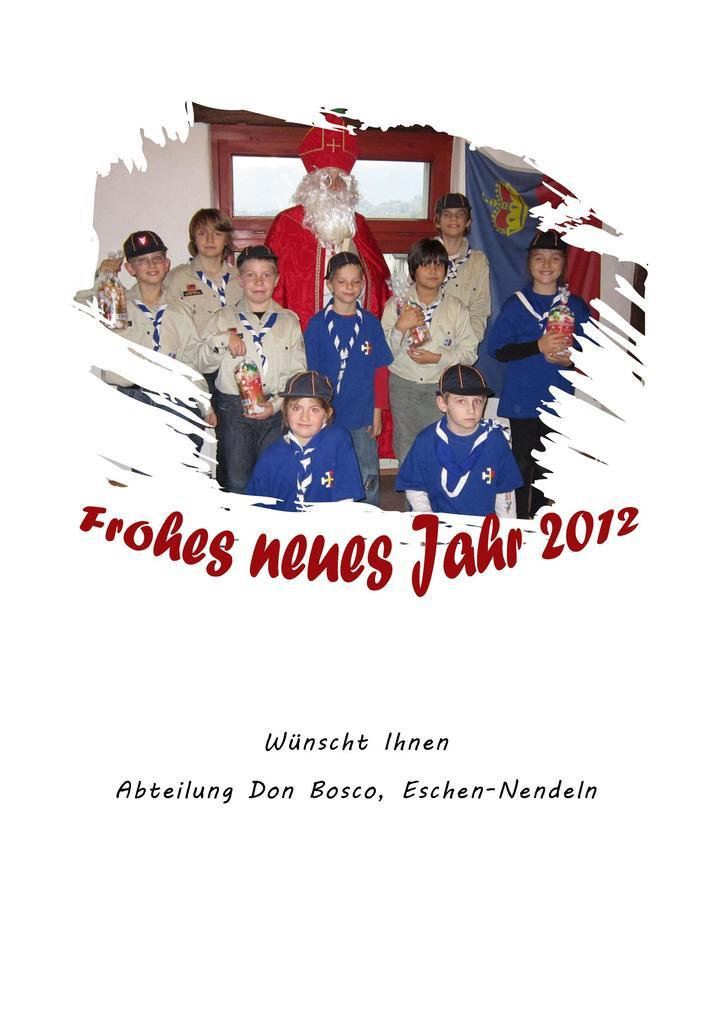What is depicted on the poster in the image? There is a poster in the image that contains people standing and holding something in their hands. What can be seen on the wall behind the people in the poster? There is a flag on the wall in the poster. What is the background of the scene in the poster? The background of the scene in the poster is a wall. Can you tell me how many kittens are playing with a cork and a pickle in the image? There are no kittens, corks, or pickles present in the image. 